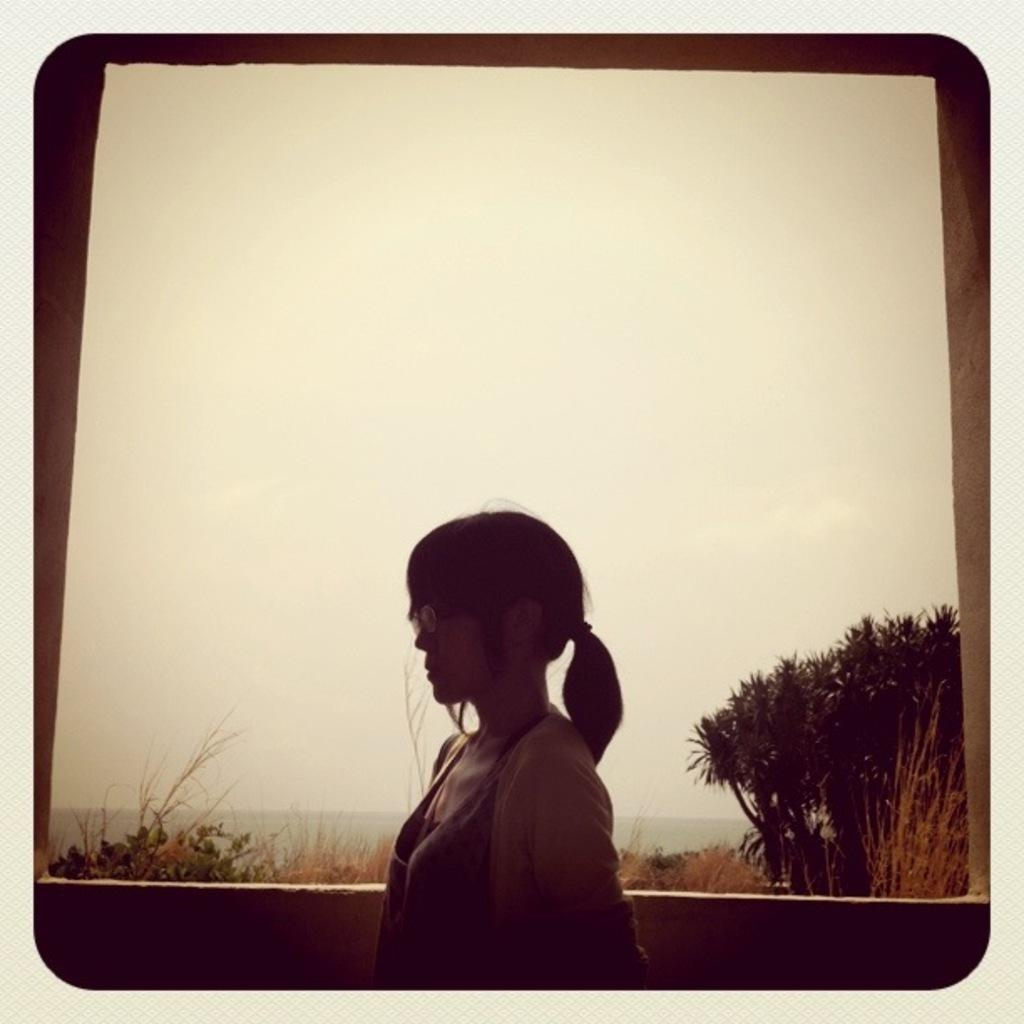What is the main subject of the image? There is a woman in the image. What is located behind the woman in the image? There is a wall in the image. What type of vegetation can be seen in the background of the image? There are plants and trees in the background of the image. What part of the natural environment is visible in the image? The sky is visible in the background of the image. What type of observation can be made about the snail in the image? There is no snail present in the image. What news headline is visible on the wall in the image? There is no news headline visible on the wall in the image. 